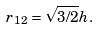<formula> <loc_0><loc_0><loc_500><loc_500>r _ { 1 2 } = \sqrt { 3 / 2 } h .</formula> 